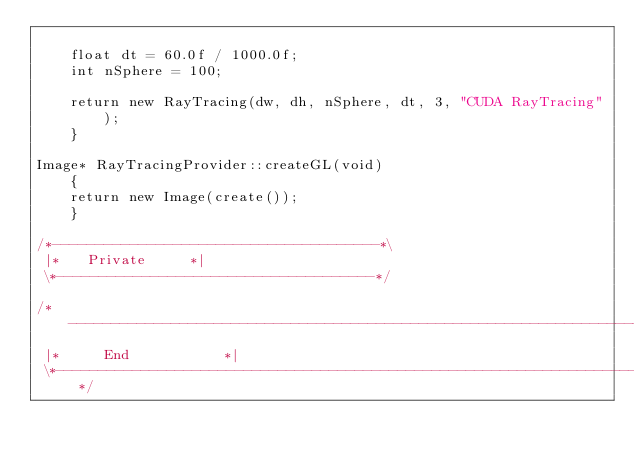Convert code to text. <code><loc_0><loc_0><loc_500><loc_500><_C++_>
    float dt = 60.0f / 1000.0f;
    int nSphere = 100;

    return new RayTracing(dw, dh, nSphere, dt, 3, "CUDA RayTracing");
    }

Image* RayTracingProvider::createGL(void)
    {
    return new Image(create());
    }

/*--------------------------------------*\
 |*		Private			*|
 \*-------------------------------------*/

/*----------------------------------------------------------------------*\
 |*			End	 					*|
 \*---------------------------------------------------------------------*/
</code> 